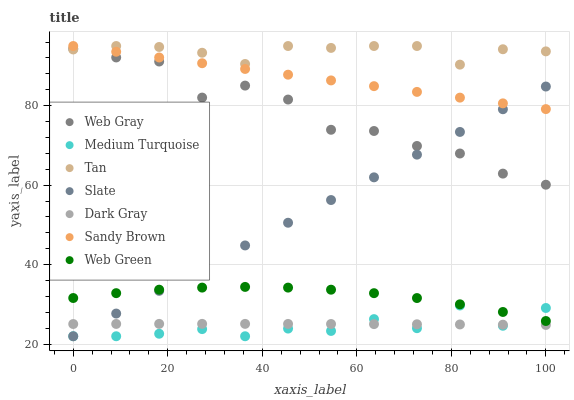Does Medium Turquoise have the minimum area under the curve?
Answer yes or no. Yes. Does Tan have the maximum area under the curve?
Answer yes or no. Yes. Does Slate have the minimum area under the curve?
Answer yes or no. No. Does Slate have the maximum area under the curve?
Answer yes or no. No. Is Slate the smoothest?
Answer yes or no. Yes. Is Web Gray the roughest?
Answer yes or no. Yes. Is Web Green the smoothest?
Answer yes or no. No. Is Web Green the roughest?
Answer yes or no. No. Does Slate have the lowest value?
Answer yes or no. Yes. Does Web Green have the lowest value?
Answer yes or no. No. Does Sandy Brown have the highest value?
Answer yes or no. Yes. Does Slate have the highest value?
Answer yes or no. No. Is Dark Gray less than Web Gray?
Answer yes or no. Yes. Is Web Gray greater than Web Green?
Answer yes or no. Yes. Does Web Green intersect Slate?
Answer yes or no. Yes. Is Web Green less than Slate?
Answer yes or no. No. Is Web Green greater than Slate?
Answer yes or no. No. Does Dark Gray intersect Web Gray?
Answer yes or no. No. 